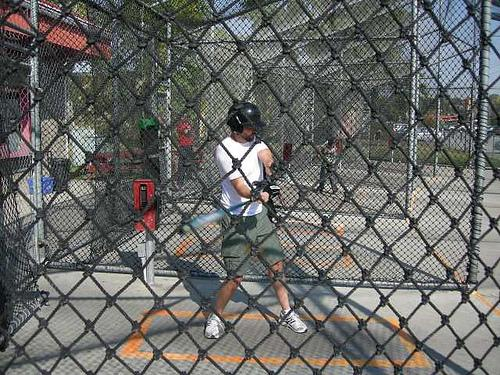What is the man standing in? Please explain your reasoning. batting cage. The man is standing inside of a batters cage where he is practicing ball. 